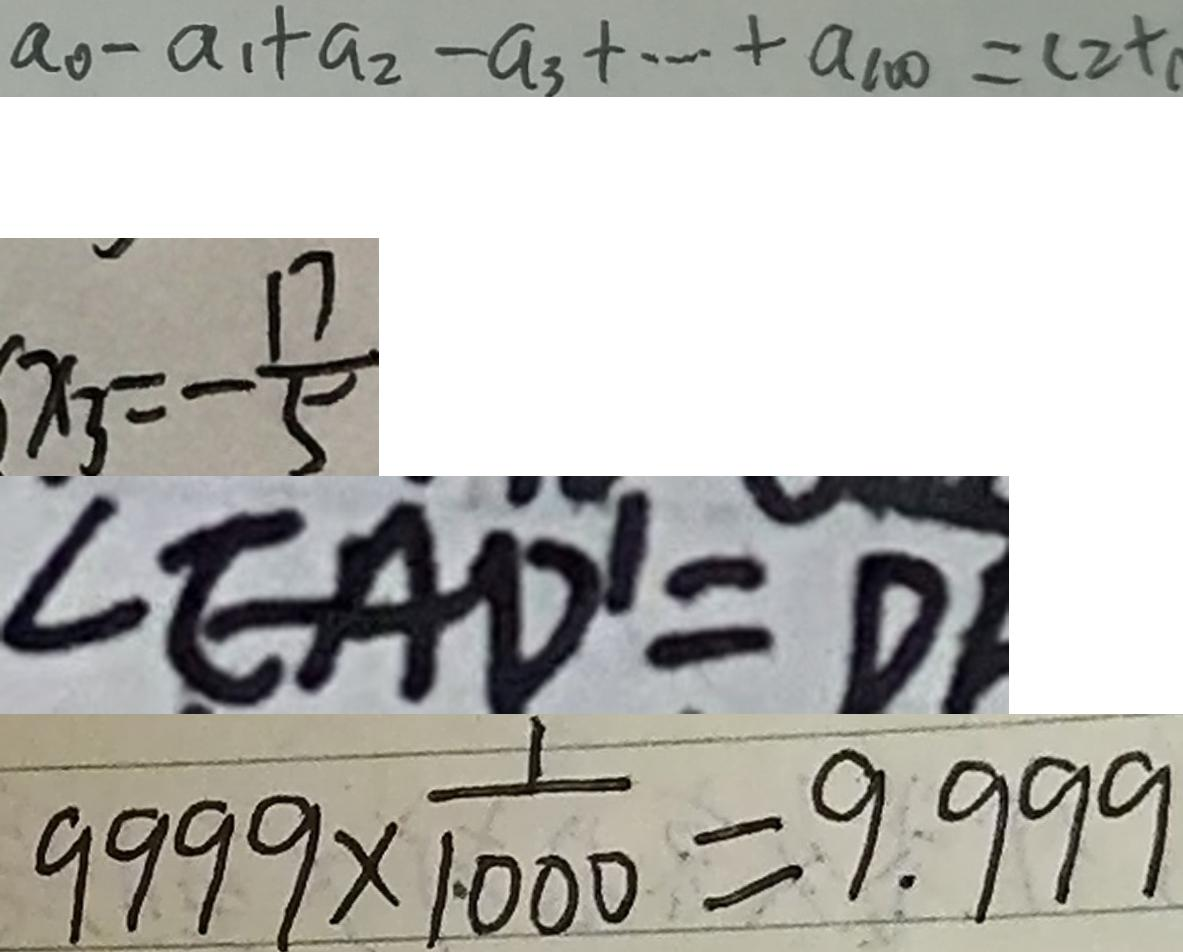Convert formula to latex. <formula><loc_0><loc_0><loc_500><loc_500>a _ { 0 } - a _ { 1 } + a _ { 2 } - a _ { 3 } + \cdots + a _ { 1 0 0 } = c 2 + 
 x _ { 3 } = - \frac { 1 7 } { 5 } 
 \angle E A D ^ { \prime } = D 
 9 9 9 9 \times \frac { 1 } { 1 0 0 0 } = 9 . 9 9 9</formula> 